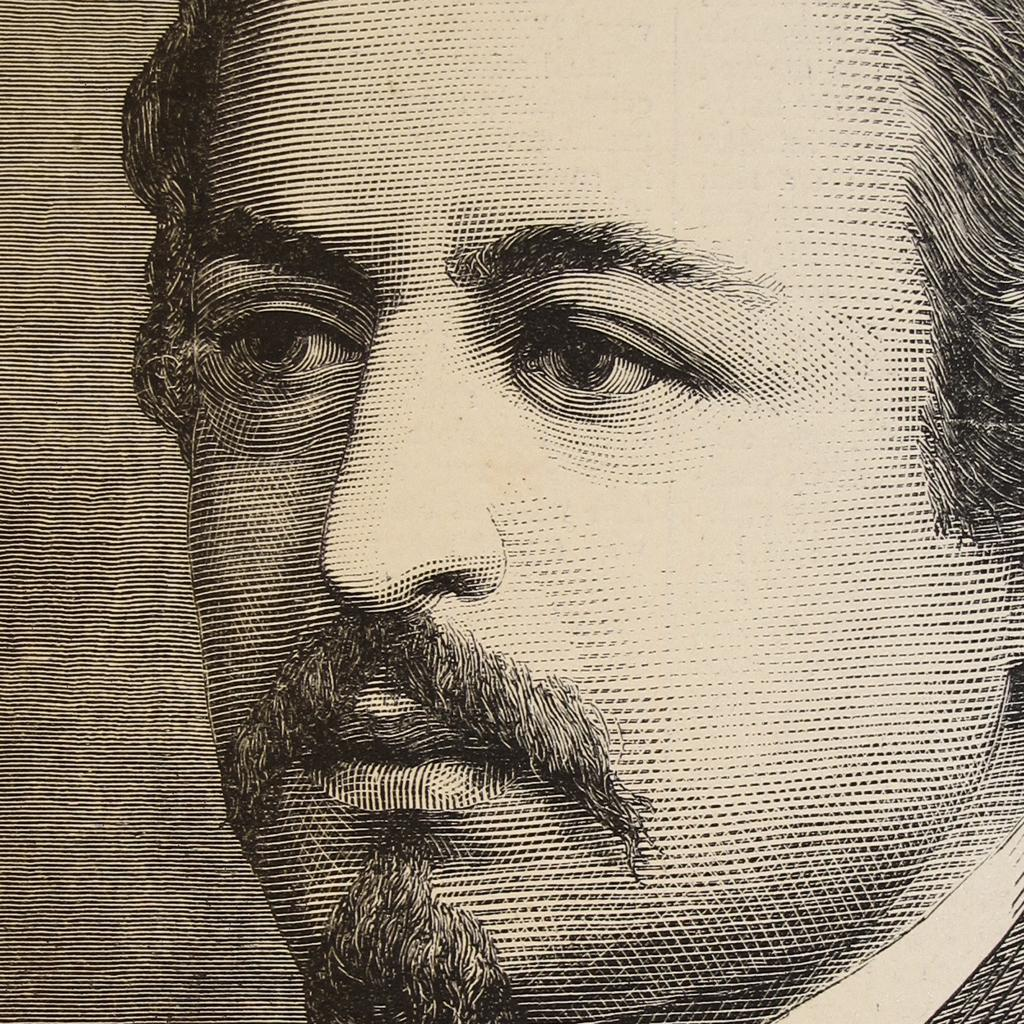What is depicted in the image? There is a sketch of a person's face in the image. How many flowers are present in the sketch of the person's face? There are no flowers present in the sketch of the person's face; it is a drawing of a face, not a scene with flowers. 